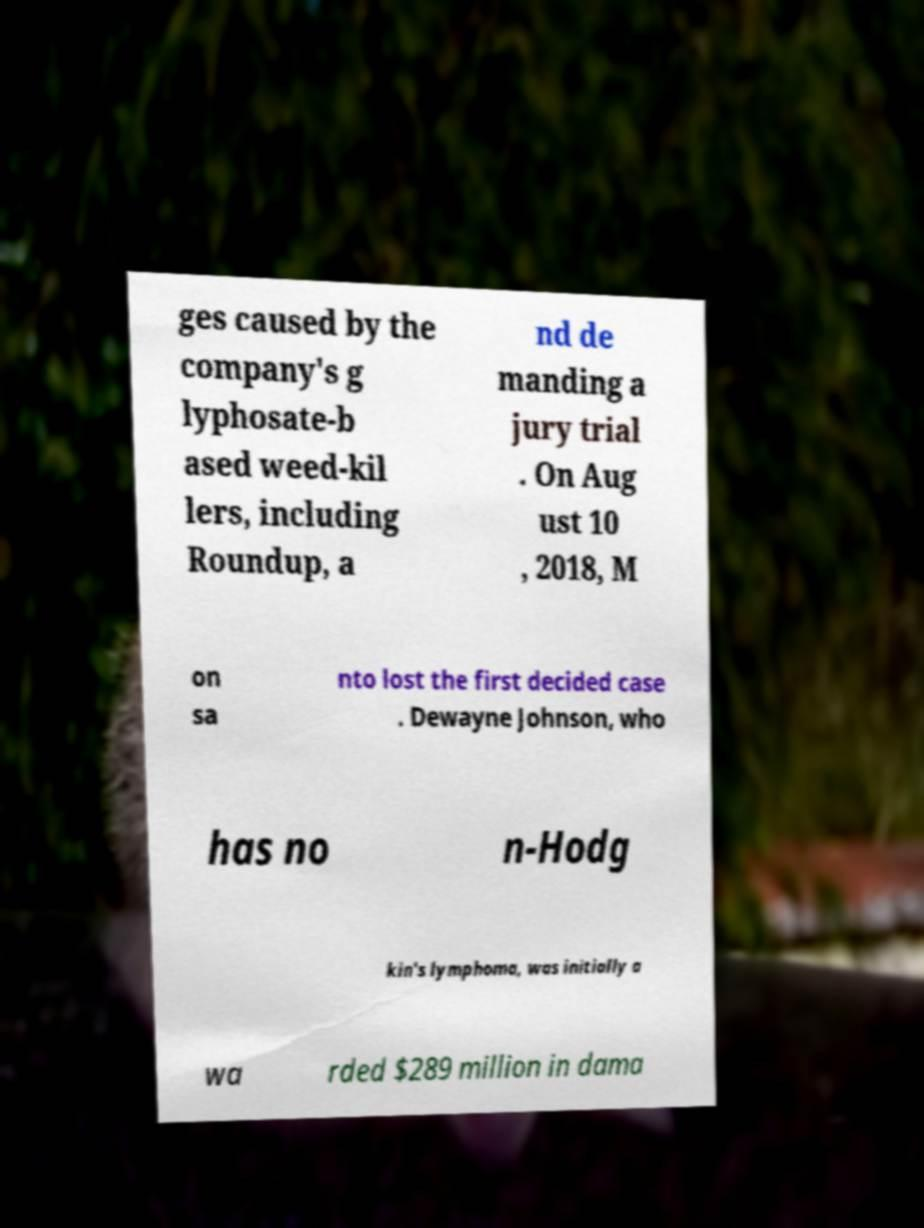Please identify and transcribe the text found in this image. ges caused by the company's g lyphosate-b ased weed-kil lers, including Roundup, a nd de manding a jury trial . On Aug ust 10 , 2018, M on sa nto lost the first decided case . Dewayne Johnson, who has no n-Hodg kin's lymphoma, was initially a wa rded $289 million in dama 